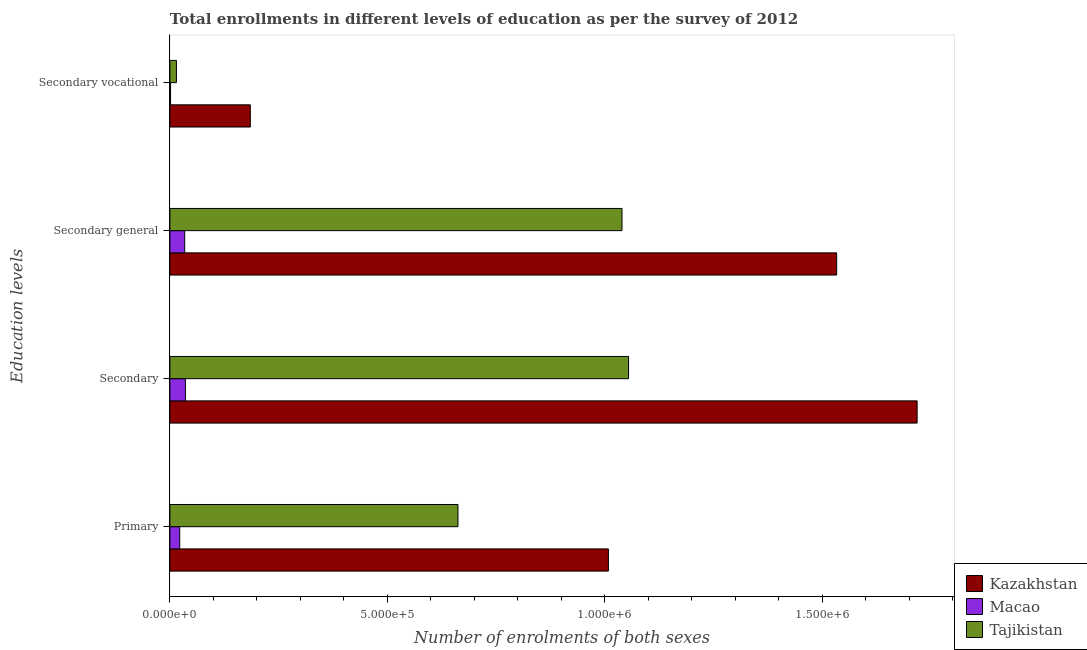How many groups of bars are there?
Offer a terse response. 4. What is the label of the 4th group of bars from the top?
Your answer should be compact. Primary. What is the number of enrolments in secondary education in Macao?
Offer a very short reply. 3.57e+04. Across all countries, what is the maximum number of enrolments in secondary general education?
Your answer should be compact. 1.53e+06. Across all countries, what is the minimum number of enrolments in secondary education?
Provide a short and direct response. 3.57e+04. In which country was the number of enrolments in secondary general education maximum?
Your answer should be very brief. Kazakhstan. In which country was the number of enrolments in secondary general education minimum?
Keep it short and to the point. Macao. What is the total number of enrolments in secondary vocational education in the graph?
Provide a succinct answer. 2.02e+05. What is the difference between the number of enrolments in primary education in Kazakhstan and that in Tajikistan?
Give a very brief answer. 3.46e+05. What is the difference between the number of enrolments in primary education in Macao and the number of enrolments in secondary vocational education in Kazakhstan?
Give a very brief answer. -1.62e+05. What is the average number of enrolments in secondary vocational education per country?
Offer a very short reply. 6.72e+04. What is the difference between the number of enrolments in primary education and number of enrolments in secondary education in Macao?
Offer a very short reply. -1.31e+04. What is the ratio of the number of enrolments in secondary general education in Kazakhstan to that in Tajikistan?
Provide a short and direct response. 1.47. Is the number of enrolments in secondary education in Tajikistan less than that in Kazakhstan?
Your response must be concise. Yes. What is the difference between the highest and the second highest number of enrolments in primary education?
Offer a terse response. 3.46e+05. What is the difference between the highest and the lowest number of enrolments in secondary education?
Offer a very short reply. 1.68e+06. In how many countries, is the number of enrolments in secondary education greater than the average number of enrolments in secondary education taken over all countries?
Ensure brevity in your answer.  2. What does the 1st bar from the top in Secondary vocational represents?
Your answer should be compact. Tajikistan. What does the 1st bar from the bottom in Secondary general represents?
Give a very brief answer. Kazakhstan. Is it the case that in every country, the sum of the number of enrolments in primary education and number of enrolments in secondary education is greater than the number of enrolments in secondary general education?
Offer a terse response. Yes. How many bars are there?
Offer a terse response. 12. How many countries are there in the graph?
Keep it short and to the point. 3. Are the values on the major ticks of X-axis written in scientific E-notation?
Provide a succinct answer. Yes. Where does the legend appear in the graph?
Provide a short and direct response. Bottom right. How many legend labels are there?
Make the answer very short. 3. How are the legend labels stacked?
Provide a short and direct response. Vertical. What is the title of the graph?
Keep it short and to the point. Total enrollments in different levels of education as per the survey of 2012. Does "Burundi" appear as one of the legend labels in the graph?
Keep it short and to the point. No. What is the label or title of the X-axis?
Your answer should be compact. Number of enrolments of both sexes. What is the label or title of the Y-axis?
Offer a very short reply. Education levels. What is the Number of enrolments of both sexes of Kazakhstan in Primary?
Provide a short and direct response. 1.01e+06. What is the Number of enrolments of both sexes in Macao in Primary?
Your answer should be very brief. 2.26e+04. What is the Number of enrolments of both sexes of Tajikistan in Primary?
Provide a short and direct response. 6.63e+05. What is the Number of enrolments of both sexes in Kazakhstan in Secondary?
Provide a short and direct response. 1.72e+06. What is the Number of enrolments of both sexes of Macao in Secondary?
Give a very brief answer. 3.57e+04. What is the Number of enrolments of both sexes in Tajikistan in Secondary?
Your response must be concise. 1.05e+06. What is the Number of enrolments of both sexes in Kazakhstan in Secondary general?
Offer a very short reply. 1.53e+06. What is the Number of enrolments of both sexes in Macao in Secondary general?
Your answer should be very brief. 3.41e+04. What is the Number of enrolments of both sexes in Tajikistan in Secondary general?
Your response must be concise. 1.04e+06. What is the Number of enrolments of both sexes in Kazakhstan in Secondary vocational?
Make the answer very short. 1.85e+05. What is the Number of enrolments of both sexes in Macao in Secondary vocational?
Give a very brief answer. 1601. What is the Number of enrolments of both sexes in Tajikistan in Secondary vocational?
Provide a short and direct response. 1.51e+04. Across all Education levels, what is the maximum Number of enrolments of both sexes in Kazakhstan?
Keep it short and to the point. 1.72e+06. Across all Education levels, what is the maximum Number of enrolments of both sexes in Macao?
Give a very brief answer. 3.57e+04. Across all Education levels, what is the maximum Number of enrolments of both sexes in Tajikistan?
Your answer should be very brief. 1.05e+06. Across all Education levels, what is the minimum Number of enrolments of both sexes of Kazakhstan?
Provide a succinct answer. 1.85e+05. Across all Education levels, what is the minimum Number of enrolments of both sexes in Macao?
Give a very brief answer. 1601. Across all Education levels, what is the minimum Number of enrolments of both sexes in Tajikistan?
Offer a very short reply. 1.51e+04. What is the total Number of enrolments of both sexes in Kazakhstan in the graph?
Provide a short and direct response. 4.45e+06. What is the total Number of enrolments of both sexes of Macao in the graph?
Offer a terse response. 9.41e+04. What is the total Number of enrolments of both sexes of Tajikistan in the graph?
Your answer should be compact. 2.77e+06. What is the difference between the Number of enrolments of both sexes in Kazakhstan in Primary and that in Secondary?
Offer a terse response. -7.10e+05. What is the difference between the Number of enrolments of both sexes of Macao in Primary and that in Secondary?
Your answer should be compact. -1.31e+04. What is the difference between the Number of enrolments of both sexes of Tajikistan in Primary and that in Secondary?
Make the answer very short. -3.92e+05. What is the difference between the Number of enrolments of both sexes in Kazakhstan in Primary and that in Secondary general?
Your response must be concise. -5.25e+05. What is the difference between the Number of enrolments of both sexes in Macao in Primary and that in Secondary general?
Provide a short and direct response. -1.15e+04. What is the difference between the Number of enrolments of both sexes in Tajikistan in Primary and that in Secondary general?
Your response must be concise. -3.77e+05. What is the difference between the Number of enrolments of both sexes of Kazakhstan in Primary and that in Secondary vocational?
Keep it short and to the point. 8.23e+05. What is the difference between the Number of enrolments of both sexes of Macao in Primary and that in Secondary vocational?
Your response must be concise. 2.10e+04. What is the difference between the Number of enrolments of both sexes of Tajikistan in Primary and that in Secondary vocational?
Your answer should be compact. 6.47e+05. What is the difference between the Number of enrolments of both sexes of Kazakhstan in Secondary and that in Secondary general?
Offer a very short reply. 1.85e+05. What is the difference between the Number of enrolments of both sexes of Macao in Secondary and that in Secondary general?
Give a very brief answer. 1601. What is the difference between the Number of enrolments of both sexes of Tajikistan in Secondary and that in Secondary general?
Ensure brevity in your answer.  1.51e+04. What is the difference between the Number of enrolments of both sexes of Kazakhstan in Secondary and that in Secondary vocational?
Make the answer very short. 1.53e+06. What is the difference between the Number of enrolments of both sexes of Macao in Secondary and that in Secondary vocational?
Your answer should be very brief. 3.41e+04. What is the difference between the Number of enrolments of both sexes of Tajikistan in Secondary and that in Secondary vocational?
Make the answer very short. 1.04e+06. What is the difference between the Number of enrolments of both sexes in Kazakhstan in Secondary general and that in Secondary vocational?
Provide a short and direct response. 1.35e+06. What is the difference between the Number of enrolments of both sexes in Macao in Secondary general and that in Secondary vocational?
Provide a short and direct response. 3.25e+04. What is the difference between the Number of enrolments of both sexes in Tajikistan in Secondary general and that in Secondary vocational?
Provide a short and direct response. 1.02e+06. What is the difference between the Number of enrolments of both sexes in Kazakhstan in Primary and the Number of enrolments of both sexes in Macao in Secondary?
Provide a short and direct response. 9.73e+05. What is the difference between the Number of enrolments of both sexes in Kazakhstan in Primary and the Number of enrolments of both sexes in Tajikistan in Secondary?
Give a very brief answer. -4.63e+04. What is the difference between the Number of enrolments of both sexes of Macao in Primary and the Number of enrolments of both sexes of Tajikistan in Secondary?
Offer a terse response. -1.03e+06. What is the difference between the Number of enrolments of both sexes in Kazakhstan in Primary and the Number of enrolments of both sexes in Macao in Secondary general?
Make the answer very short. 9.74e+05. What is the difference between the Number of enrolments of both sexes of Kazakhstan in Primary and the Number of enrolments of both sexes of Tajikistan in Secondary general?
Make the answer very short. -3.13e+04. What is the difference between the Number of enrolments of both sexes of Macao in Primary and the Number of enrolments of both sexes of Tajikistan in Secondary general?
Give a very brief answer. -1.02e+06. What is the difference between the Number of enrolments of both sexes in Kazakhstan in Primary and the Number of enrolments of both sexes in Macao in Secondary vocational?
Offer a very short reply. 1.01e+06. What is the difference between the Number of enrolments of both sexes of Kazakhstan in Primary and the Number of enrolments of both sexes of Tajikistan in Secondary vocational?
Provide a short and direct response. 9.93e+05. What is the difference between the Number of enrolments of both sexes in Macao in Primary and the Number of enrolments of both sexes in Tajikistan in Secondary vocational?
Make the answer very short. 7574. What is the difference between the Number of enrolments of both sexes of Kazakhstan in Secondary and the Number of enrolments of both sexes of Macao in Secondary general?
Your response must be concise. 1.68e+06. What is the difference between the Number of enrolments of both sexes of Kazakhstan in Secondary and the Number of enrolments of both sexes of Tajikistan in Secondary general?
Ensure brevity in your answer.  6.79e+05. What is the difference between the Number of enrolments of both sexes of Macao in Secondary and the Number of enrolments of both sexes of Tajikistan in Secondary general?
Offer a terse response. -1.00e+06. What is the difference between the Number of enrolments of both sexes of Kazakhstan in Secondary and the Number of enrolments of both sexes of Macao in Secondary vocational?
Your answer should be very brief. 1.72e+06. What is the difference between the Number of enrolments of both sexes of Kazakhstan in Secondary and the Number of enrolments of both sexes of Tajikistan in Secondary vocational?
Your response must be concise. 1.70e+06. What is the difference between the Number of enrolments of both sexes in Macao in Secondary and the Number of enrolments of both sexes in Tajikistan in Secondary vocational?
Offer a terse response. 2.07e+04. What is the difference between the Number of enrolments of both sexes of Kazakhstan in Secondary general and the Number of enrolments of both sexes of Macao in Secondary vocational?
Offer a very short reply. 1.53e+06. What is the difference between the Number of enrolments of both sexes in Kazakhstan in Secondary general and the Number of enrolments of both sexes in Tajikistan in Secondary vocational?
Give a very brief answer. 1.52e+06. What is the difference between the Number of enrolments of both sexes of Macao in Secondary general and the Number of enrolments of both sexes of Tajikistan in Secondary vocational?
Your response must be concise. 1.91e+04. What is the average Number of enrolments of both sexes of Kazakhstan per Education levels?
Provide a succinct answer. 1.11e+06. What is the average Number of enrolments of both sexes in Macao per Education levels?
Your answer should be compact. 2.35e+04. What is the average Number of enrolments of both sexes in Tajikistan per Education levels?
Ensure brevity in your answer.  6.93e+05. What is the difference between the Number of enrolments of both sexes of Kazakhstan and Number of enrolments of both sexes of Macao in Primary?
Your answer should be very brief. 9.86e+05. What is the difference between the Number of enrolments of both sexes in Kazakhstan and Number of enrolments of both sexes in Tajikistan in Primary?
Ensure brevity in your answer.  3.46e+05. What is the difference between the Number of enrolments of both sexes of Macao and Number of enrolments of both sexes of Tajikistan in Primary?
Your response must be concise. -6.40e+05. What is the difference between the Number of enrolments of both sexes of Kazakhstan and Number of enrolments of both sexes of Macao in Secondary?
Keep it short and to the point. 1.68e+06. What is the difference between the Number of enrolments of both sexes of Kazakhstan and Number of enrolments of both sexes of Tajikistan in Secondary?
Make the answer very short. 6.64e+05. What is the difference between the Number of enrolments of both sexes in Macao and Number of enrolments of both sexes in Tajikistan in Secondary?
Provide a short and direct response. -1.02e+06. What is the difference between the Number of enrolments of both sexes of Kazakhstan and Number of enrolments of both sexes of Macao in Secondary general?
Your response must be concise. 1.50e+06. What is the difference between the Number of enrolments of both sexes of Kazakhstan and Number of enrolments of both sexes of Tajikistan in Secondary general?
Your response must be concise. 4.94e+05. What is the difference between the Number of enrolments of both sexes in Macao and Number of enrolments of both sexes in Tajikistan in Secondary general?
Ensure brevity in your answer.  -1.01e+06. What is the difference between the Number of enrolments of both sexes in Kazakhstan and Number of enrolments of both sexes in Macao in Secondary vocational?
Ensure brevity in your answer.  1.83e+05. What is the difference between the Number of enrolments of both sexes of Kazakhstan and Number of enrolments of both sexes of Tajikistan in Secondary vocational?
Offer a terse response. 1.70e+05. What is the difference between the Number of enrolments of both sexes in Macao and Number of enrolments of both sexes in Tajikistan in Secondary vocational?
Ensure brevity in your answer.  -1.35e+04. What is the ratio of the Number of enrolments of both sexes of Kazakhstan in Primary to that in Secondary?
Offer a terse response. 0.59. What is the ratio of the Number of enrolments of both sexes in Macao in Primary to that in Secondary?
Your answer should be very brief. 0.63. What is the ratio of the Number of enrolments of both sexes in Tajikistan in Primary to that in Secondary?
Your answer should be compact. 0.63. What is the ratio of the Number of enrolments of both sexes of Kazakhstan in Primary to that in Secondary general?
Ensure brevity in your answer.  0.66. What is the ratio of the Number of enrolments of both sexes of Macao in Primary to that in Secondary general?
Your answer should be very brief. 0.66. What is the ratio of the Number of enrolments of both sexes of Tajikistan in Primary to that in Secondary general?
Your response must be concise. 0.64. What is the ratio of the Number of enrolments of both sexes of Kazakhstan in Primary to that in Secondary vocational?
Keep it short and to the point. 5.45. What is the ratio of the Number of enrolments of both sexes in Macao in Primary to that in Secondary vocational?
Provide a short and direct response. 14.14. What is the ratio of the Number of enrolments of both sexes in Tajikistan in Primary to that in Secondary vocational?
Ensure brevity in your answer.  43.96. What is the ratio of the Number of enrolments of both sexes of Kazakhstan in Secondary to that in Secondary general?
Your answer should be very brief. 1.12. What is the ratio of the Number of enrolments of both sexes of Macao in Secondary to that in Secondary general?
Offer a terse response. 1.05. What is the ratio of the Number of enrolments of both sexes of Tajikistan in Secondary to that in Secondary general?
Provide a short and direct response. 1.01. What is the ratio of the Number of enrolments of both sexes of Kazakhstan in Secondary to that in Secondary vocational?
Provide a succinct answer. 9.29. What is the ratio of the Number of enrolments of both sexes in Macao in Secondary to that in Secondary vocational?
Provide a short and direct response. 22.31. What is the ratio of the Number of enrolments of both sexes of Tajikistan in Secondary to that in Secondary vocational?
Your answer should be compact. 69.98. What is the ratio of the Number of enrolments of both sexes in Kazakhstan in Secondary general to that in Secondary vocational?
Provide a short and direct response. 8.29. What is the ratio of the Number of enrolments of both sexes in Macao in Secondary general to that in Secondary vocational?
Your answer should be compact. 21.31. What is the ratio of the Number of enrolments of both sexes of Tajikistan in Secondary general to that in Secondary vocational?
Offer a terse response. 68.98. What is the difference between the highest and the second highest Number of enrolments of both sexes in Kazakhstan?
Your response must be concise. 1.85e+05. What is the difference between the highest and the second highest Number of enrolments of both sexes in Macao?
Make the answer very short. 1601. What is the difference between the highest and the second highest Number of enrolments of both sexes in Tajikistan?
Keep it short and to the point. 1.51e+04. What is the difference between the highest and the lowest Number of enrolments of both sexes in Kazakhstan?
Keep it short and to the point. 1.53e+06. What is the difference between the highest and the lowest Number of enrolments of both sexes in Macao?
Ensure brevity in your answer.  3.41e+04. What is the difference between the highest and the lowest Number of enrolments of both sexes of Tajikistan?
Your answer should be compact. 1.04e+06. 